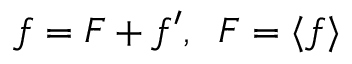<formula> <loc_0><loc_0><loc_500><loc_500>f = F + f ^ { \prime } , \, F = \langle { f } \rangle</formula> 